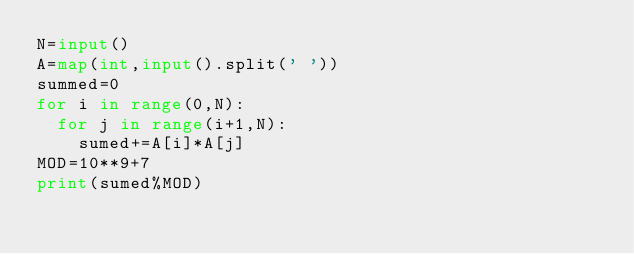Convert code to text. <code><loc_0><loc_0><loc_500><loc_500><_Python_>N=input()
A=map(int,input().split(' '))
summed=0
for i in range(0,N):
	for j in range(i+1,N):
		sumed+=A[i]*A[j]
MOD=10**9+7
print(sumed%MOD)
</code> 